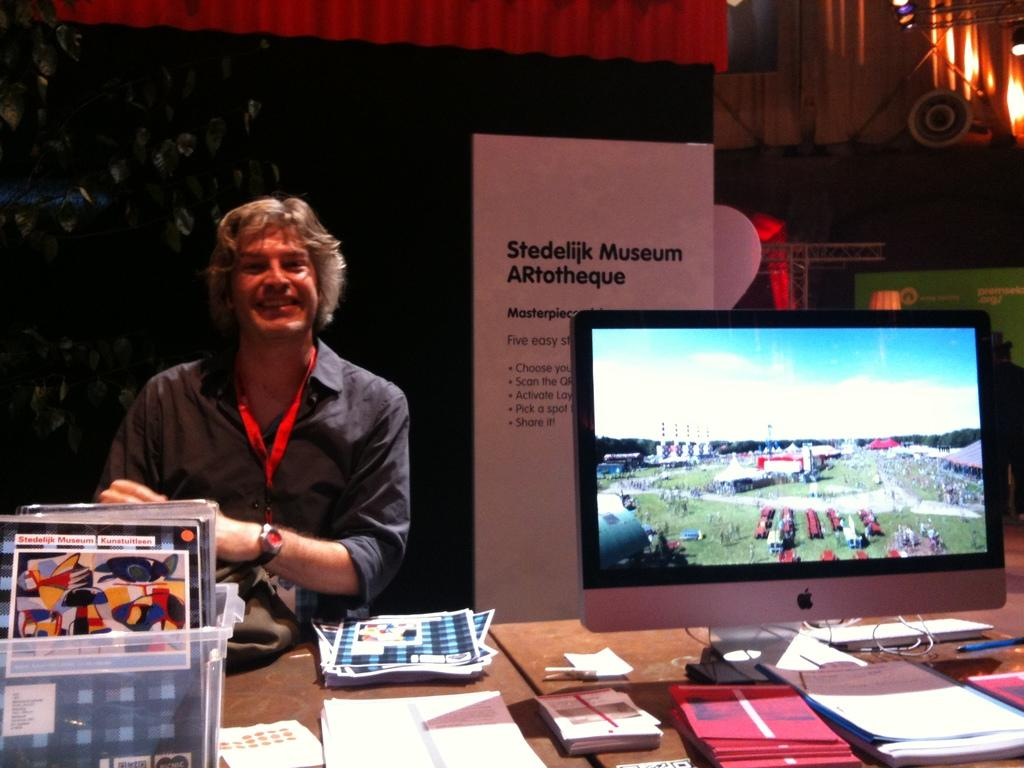<image>
Relay a brief, clear account of the picture shown. A man is smiling behind a booth with an Apple monitor at the Stedilijk Museum Artotheque. 